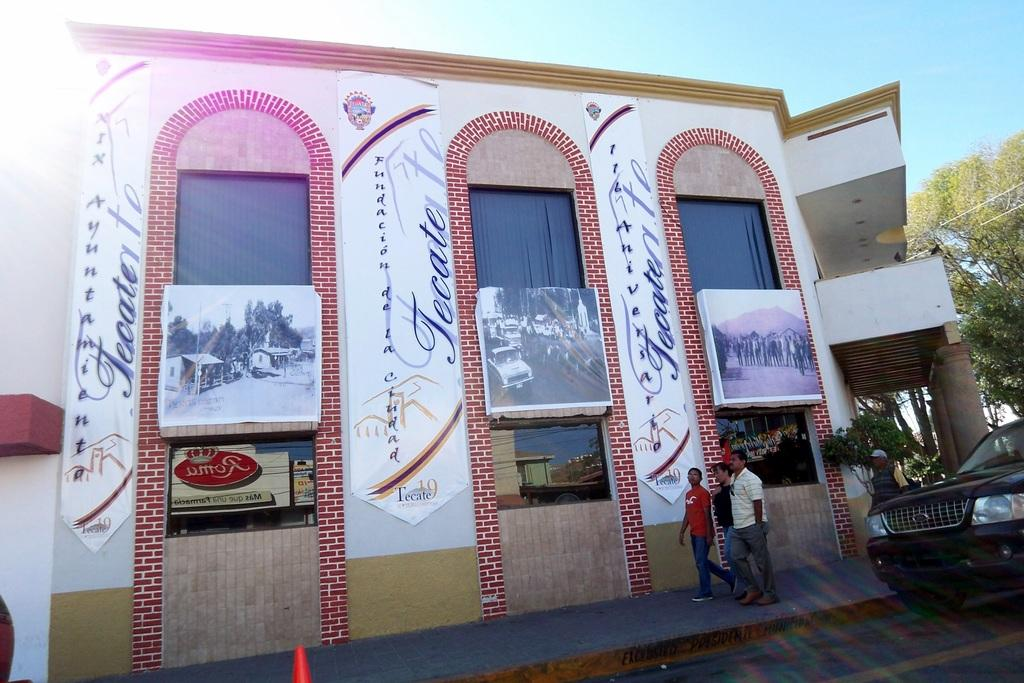What type of structures can be seen in the image? There are buildings in the image. What mode of transportation is present in the image? There is a black color car in the image. Who or what else can be seen in the image? There are people visible in the image. What type of vegetation is present in the image? There are trees in the image. What part of the natural environment is visible in the image? The sky is visible in the image. Can you see someone blowing a scarf in the image? There is no scarf or blowing action present in the image. What type of cutting tool is visible in the image? There are no cutting tools, such as scissors, present in the image. 